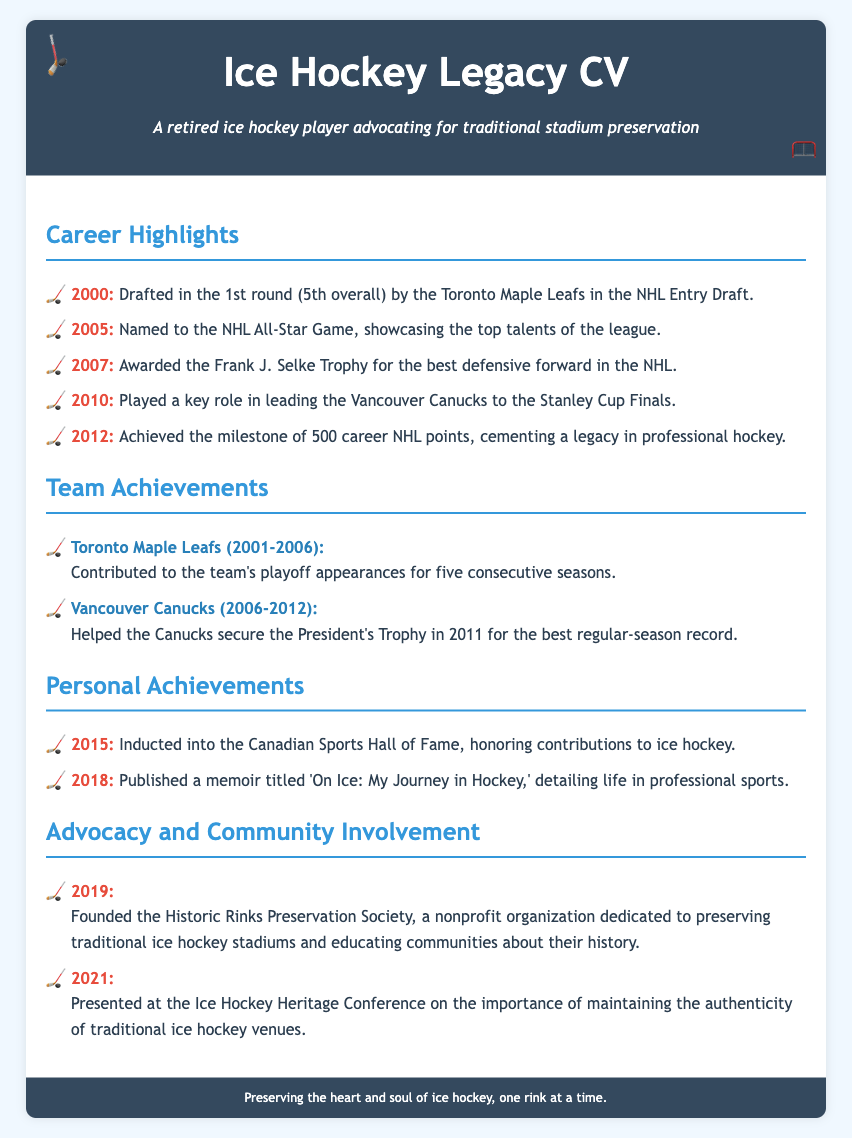What year was he drafted in the NHL Entry Draft? The document states he was drafted in the 1st round (5th overall) in the year 2000.
Answer: 2000 Which trophy did he win in 2007? The document mentions that he was awarded the Frank J. Selke Trophy in 2007 for the best defensive forward in the NHL.
Answer: Frank J. Selke Trophy How many career NHL points did he achieve by 2012? The document indicates that he achieved the milestone of 500 career NHL points in 2012.
Answer: 500 What team did he play for when they secured the President's Trophy? The document indicates he helped the Vancouver Canucks secure the President's Trophy in 2011.
Answer: Vancouver Canucks In what year did he found the Historic Rinks Preservation Society? The document states that he founded the Historic Rinks Preservation Society in 2019.
Answer: 2019 How many consecutive playoff appearances did the Toronto Maple Leafs make during his time there? The document notes that he contributed to the team's playoff appearances for five consecutive seasons with the Toronto Maple Leafs.
Answer: Five What is the title of his memoir published in 2018? The document mentions that his memoir titled 'On Ice: My Journey in Hockey' was published in 2018.
Answer: On Ice: My Journey in Hockey What significant contribution to ice hockey does the document mention he made after his retirement? The document notes that he presents at the Ice Hockey Heritage Conference on maintaining the authenticity of traditional ice hockey venues.
Answer: Authenticity of traditional ice hockey venues In which hall of fame was he inducted in 2015? The document states he was inducted into the Canadian Sports Hall of Fame in 2015.
Answer: Canadian Sports Hall of Fame 